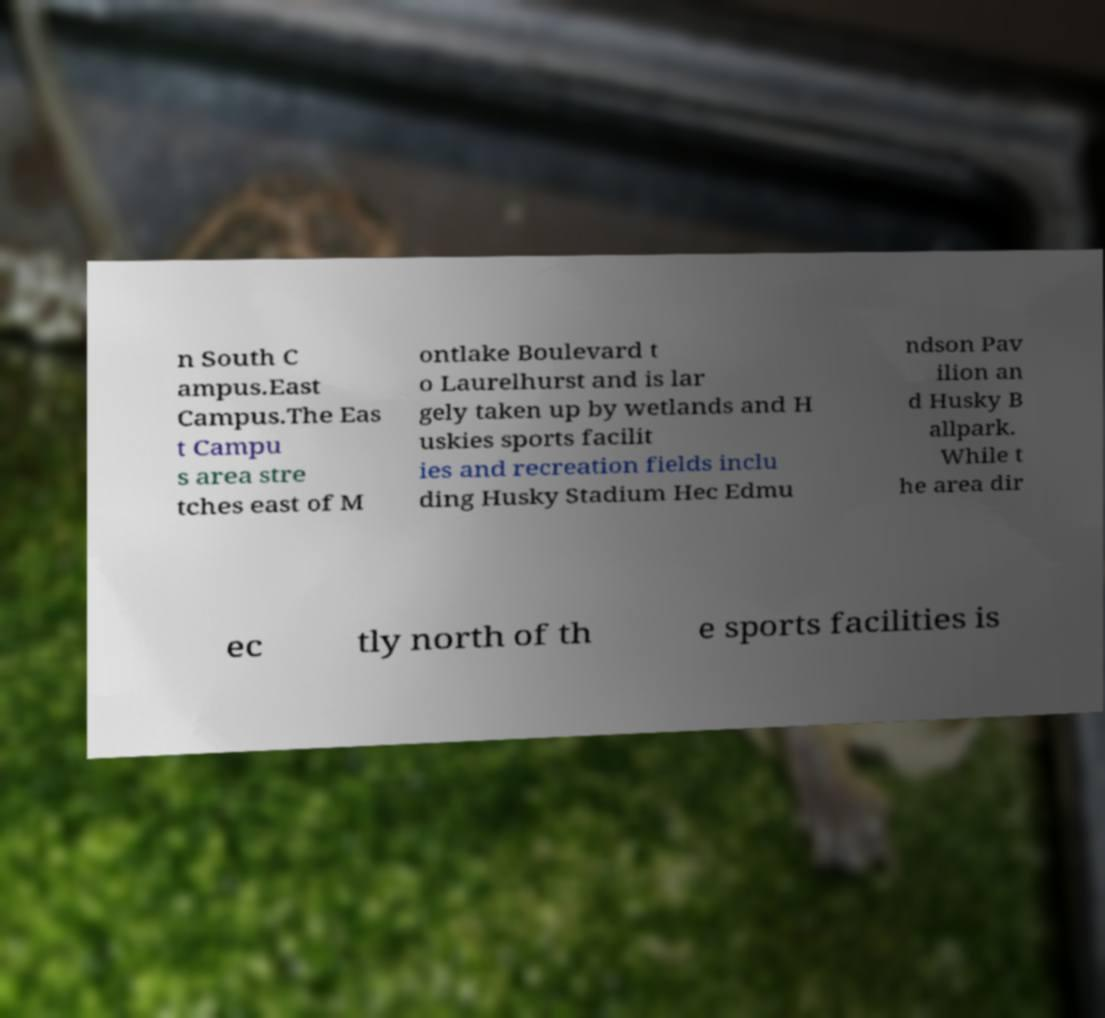Please identify and transcribe the text found in this image. n South C ampus.East Campus.The Eas t Campu s area stre tches east of M ontlake Boulevard t o Laurelhurst and is lar gely taken up by wetlands and H uskies sports facilit ies and recreation fields inclu ding Husky Stadium Hec Edmu ndson Pav ilion an d Husky B allpark. While t he area dir ec tly north of th e sports facilities is 